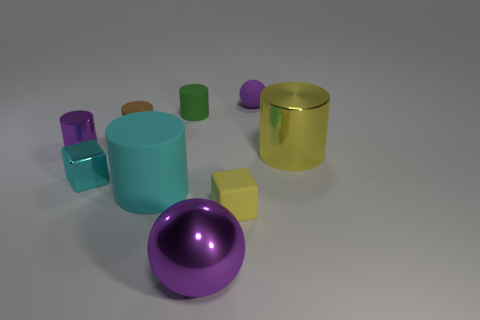Subtract all brown cylinders. How many cylinders are left? 4 Subtract 1 cylinders. How many cylinders are left? 4 Subtract all yellow cylinders. How many cylinders are left? 4 Subtract all green cylinders. Subtract all brown balls. How many cylinders are left? 4 Subtract all cubes. How many objects are left? 7 Add 4 green things. How many green things are left? 5 Add 7 large yellow metallic cylinders. How many large yellow metallic cylinders exist? 8 Subtract 0 green blocks. How many objects are left? 9 Subtract all large cyan rubber things. Subtract all small balls. How many objects are left? 7 